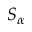<formula> <loc_0><loc_0><loc_500><loc_500>S _ { \alpha }</formula> 